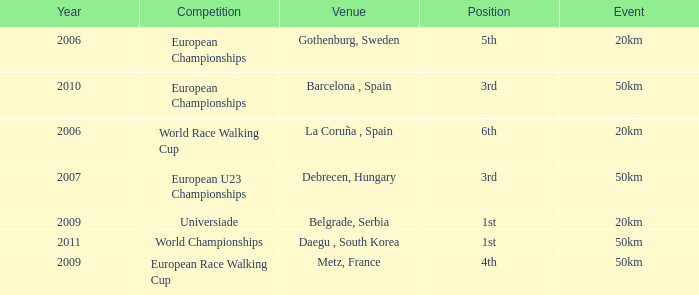Which Event has 5th Position in the European Championships Competition? 20km. 